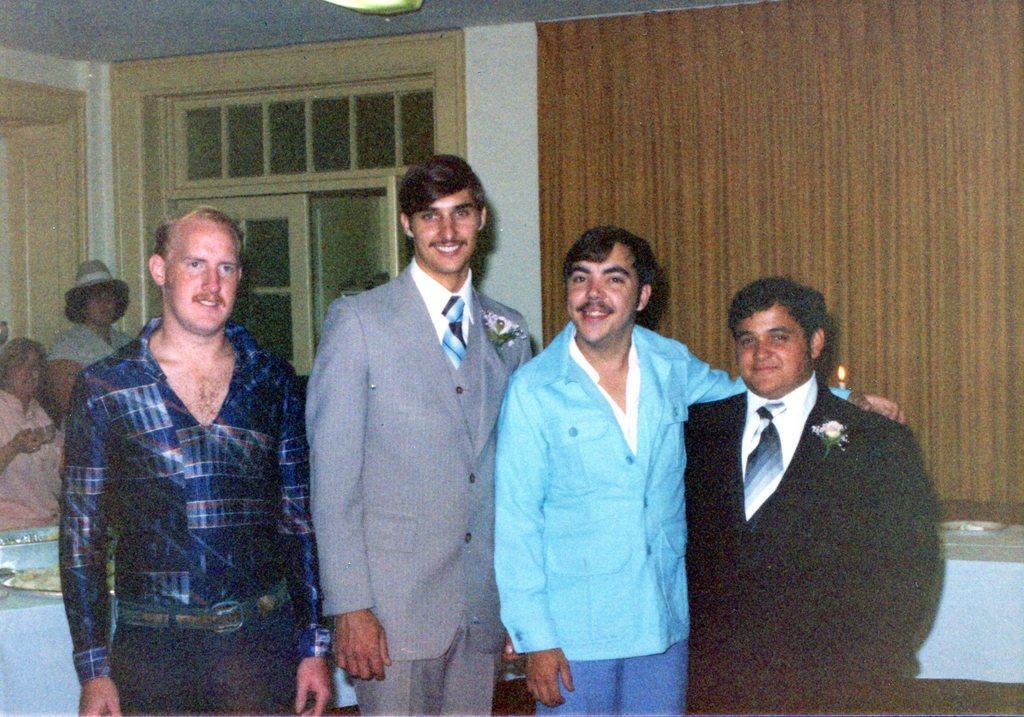Please provide a concise description of this image. In this picture we can see four men standing and smiling and in the background we can see a curtain, door and two persons. 